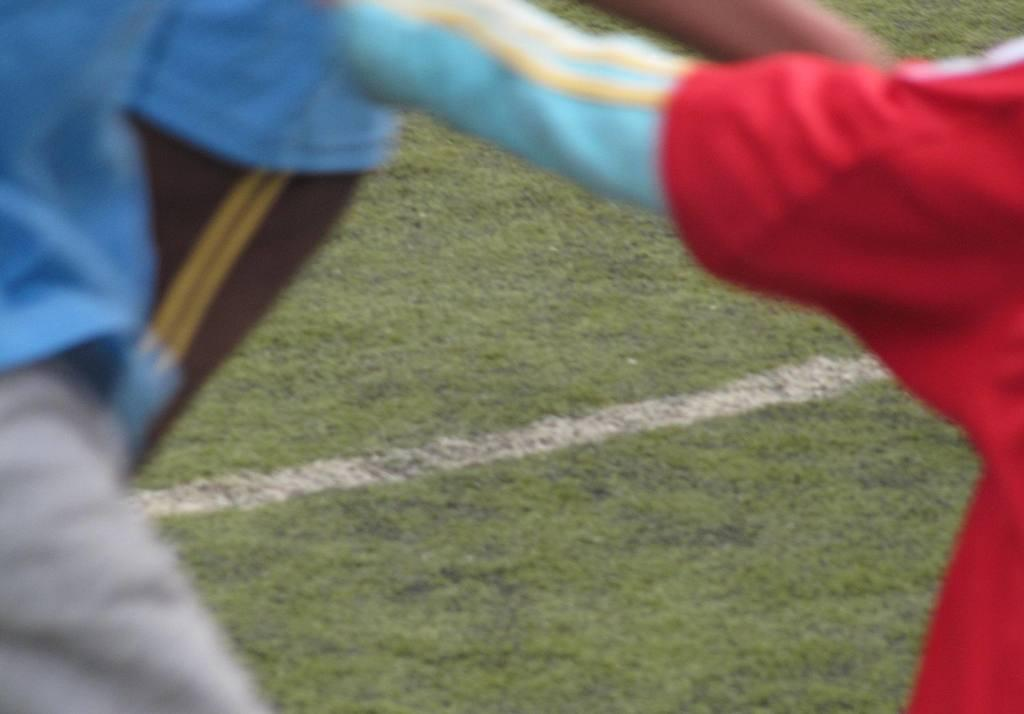What types of living organisms are present on either side of the image? There are humans on either side of the image. What is the main feature in the middle of the image? There is grass in the middle of the image. What is the distribution of the scale in the image? There is no scale present in the image, so it is not possible to determine its distribution. 